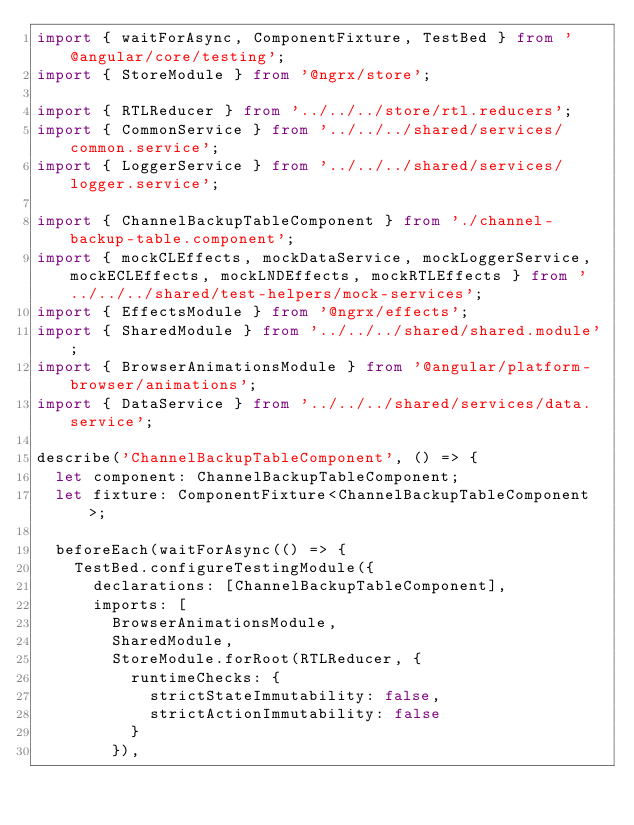<code> <loc_0><loc_0><loc_500><loc_500><_TypeScript_>import { waitForAsync, ComponentFixture, TestBed } from '@angular/core/testing';
import { StoreModule } from '@ngrx/store';

import { RTLReducer } from '../../../store/rtl.reducers';
import { CommonService } from '../../../shared/services/common.service';
import { LoggerService } from '../../../shared/services/logger.service';

import { ChannelBackupTableComponent } from './channel-backup-table.component';
import { mockCLEffects, mockDataService, mockLoggerService, mockECLEffects, mockLNDEffects, mockRTLEffects } from '../../../shared/test-helpers/mock-services';
import { EffectsModule } from '@ngrx/effects';
import { SharedModule } from '../../../shared/shared.module';
import { BrowserAnimationsModule } from '@angular/platform-browser/animations';
import { DataService } from '../../../shared/services/data.service';

describe('ChannelBackupTableComponent', () => {
  let component: ChannelBackupTableComponent;
  let fixture: ComponentFixture<ChannelBackupTableComponent>;

  beforeEach(waitForAsync(() => {
    TestBed.configureTestingModule({
      declarations: [ChannelBackupTableComponent],
      imports: [
        BrowserAnimationsModule,
        SharedModule,
        StoreModule.forRoot(RTLReducer, {
          runtimeChecks: {
            strictStateImmutability: false,
            strictActionImmutability: false
          }
        }),</code> 